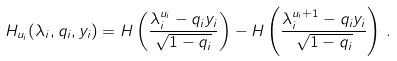<formula> <loc_0><loc_0><loc_500><loc_500>H _ { u _ { i } } ( \lambda _ { i } , q _ { i } , y _ { i } ) = H \left ( \frac { \lambda _ { i } ^ { u _ { i } } - q _ { i } y _ { i } } { \sqrt { 1 - q _ { i } } } \right ) - H \left ( \frac { \lambda _ { i } ^ { u _ { i } + 1 } - q _ { i } y _ { i } } { \sqrt { 1 - q _ { i } } } \right ) \, .</formula> 